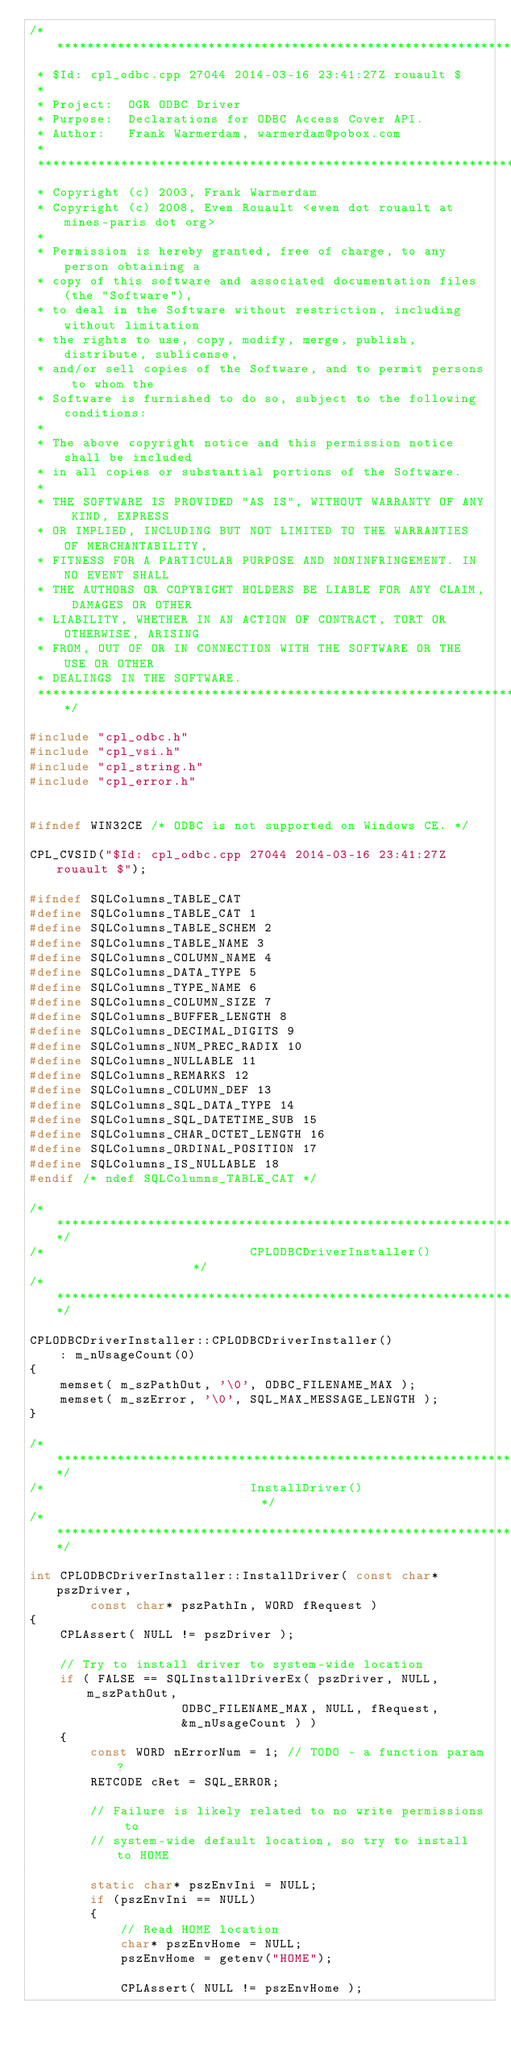<code> <loc_0><loc_0><loc_500><loc_500><_C++_>/******************************************************************************
 * $Id: cpl_odbc.cpp 27044 2014-03-16 23:41:27Z rouault $
 *
 * Project:  OGR ODBC Driver
 * Purpose:  Declarations for ODBC Access Cover API.
 * Author:   Frank Warmerdam, warmerdam@pobox.com
 *
 ******************************************************************************
 * Copyright (c) 2003, Frank Warmerdam
 * Copyright (c) 2008, Even Rouault <even dot rouault at mines-paris dot org>
 *
 * Permission is hereby granted, free of charge, to any person obtaining a
 * copy of this software and associated documentation files (the "Software"),
 * to deal in the Software without restriction, including without limitation
 * the rights to use, copy, modify, merge, publish, distribute, sublicense,
 * and/or sell copies of the Software, and to permit persons to whom the
 * Software is furnished to do so, subject to the following conditions:
 *
 * The above copyright notice and this permission notice shall be included
 * in all copies or substantial portions of the Software.
 *
 * THE SOFTWARE IS PROVIDED "AS IS", WITHOUT WARRANTY OF ANY KIND, EXPRESS
 * OR IMPLIED, INCLUDING BUT NOT LIMITED TO THE WARRANTIES OF MERCHANTABILITY,
 * FITNESS FOR A PARTICULAR PURPOSE AND NONINFRINGEMENT. IN NO EVENT SHALL
 * THE AUTHORS OR COPYRIGHT HOLDERS BE LIABLE FOR ANY CLAIM, DAMAGES OR OTHER
 * LIABILITY, WHETHER IN AN ACTION OF CONTRACT, TORT OR OTHERWISE, ARISING
 * FROM, OUT OF OR IN CONNECTION WITH THE SOFTWARE OR THE USE OR OTHER
 * DEALINGS IN THE SOFTWARE.
 ****************************************************************************/

#include "cpl_odbc.h"
#include "cpl_vsi.h"
#include "cpl_string.h"
#include "cpl_error.h"


#ifndef WIN32CE /* ODBC is not supported on Windows CE. */

CPL_CVSID("$Id: cpl_odbc.cpp 27044 2014-03-16 23:41:27Z rouault $");

#ifndef SQLColumns_TABLE_CAT 
#define SQLColumns_TABLE_CAT 1
#define SQLColumns_TABLE_SCHEM 2
#define SQLColumns_TABLE_NAME 3
#define SQLColumns_COLUMN_NAME 4
#define SQLColumns_DATA_TYPE 5
#define SQLColumns_TYPE_NAME 6
#define SQLColumns_COLUMN_SIZE 7
#define SQLColumns_BUFFER_LENGTH 8
#define SQLColumns_DECIMAL_DIGITS 9
#define SQLColumns_NUM_PREC_RADIX 10
#define SQLColumns_NULLABLE 11
#define SQLColumns_REMARKS 12
#define SQLColumns_COLUMN_DEF 13
#define SQLColumns_SQL_DATA_TYPE 14
#define SQLColumns_SQL_DATETIME_SUB 15
#define SQLColumns_CHAR_OCTET_LENGTH 16
#define SQLColumns_ORDINAL_POSITION 17
#define SQLColumns_IS_NULLABLE 18
#endif /* ndef SQLColumns_TABLE_CAT */

/************************************************************************/
/*                           CPLODBCDriverInstaller()                   */
/************************************************************************/

CPLODBCDriverInstaller::CPLODBCDriverInstaller()
    : m_nUsageCount(0)
{
    memset( m_szPathOut, '\0', ODBC_FILENAME_MAX );
    memset( m_szError, '\0', SQL_MAX_MESSAGE_LENGTH );
}

/************************************************************************/
/*                           InstallDriver()                            */
/************************************************************************/

int CPLODBCDriverInstaller::InstallDriver( const char* pszDriver,
        const char* pszPathIn, WORD fRequest )
{
    CPLAssert( NULL != pszDriver ); 

    // Try to install driver to system-wide location
    if ( FALSE == SQLInstallDriverEx( pszDriver, NULL, m_szPathOut,
                    ODBC_FILENAME_MAX, NULL, fRequest,
                    &m_nUsageCount ) )
    {
        const WORD nErrorNum = 1; // TODO - a function param?
        RETCODE cRet = SQL_ERROR;
        
        // Failure is likely related to no write permissions to
        // system-wide default location, so try to install to HOME
       
        static char* pszEnvIni = NULL;
        if (pszEnvIni == NULL)
        {
            // Read HOME location
            char* pszEnvHome = NULL;
            pszEnvHome = getenv("HOME");

            CPLAssert( NULL != pszEnvHome );</code> 